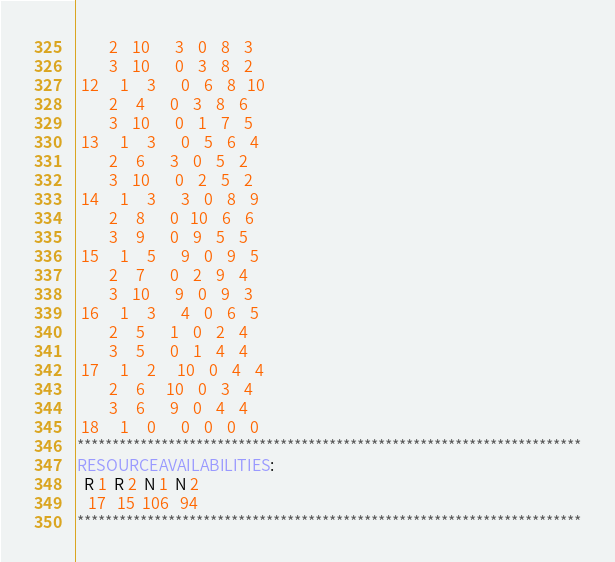<code> <loc_0><loc_0><loc_500><loc_500><_ObjectiveC_>         2    10       3    0    8    3
         3    10       0    3    8    2
 12      1     3       0    6    8   10
         2     4       0    3    8    6
         3    10       0    1    7    5
 13      1     3       0    5    6    4
         2     6       3    0    5    2
         3    10       0    2    5    2
 14      1     3       3    0    8    9
         2     8       0   10    6    6
         3     9       0    9    5    5
 15      1     5       9    0    9    5
         2     7       0    2    9    4
         3    10       9    0    9    3
 16      1     3       4    0    6    5
         2     5       1    0    2    4
         3     5       0    1    4    4
 17      1     2      10    0    4    4
         2     6      10    0    3    4
         3     6       9    0    4    4
 18      1     0       0    0    0    0
************************************************************************
RESOURCEAVAILABILITIES:
  R 1  R 2  N 1  N 2
   17   15  106   94
************************************************************************
</code> 